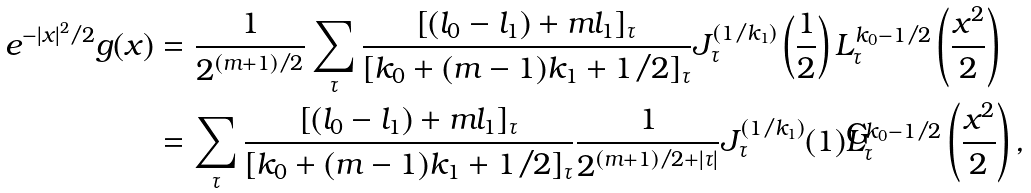<formula> <loc_0><loc_0><loc_500><loc_500>e ^ { - | x | ^ { 2 } / 2 } g ( x ) & = \frac { 1 } { 2 ^ { ( m + 1 ) / 2 } } \sum _ { \tau } \frac { [ ( l _ { 0 } - l _ { 1 } ) + m l _ { 1 } ] _ { \tau } } { [ k _ { 0 } + ( m - 1 ) k _ { 1 } + 1 / 2 ] _ { \tau } } J _ { \tau } ^ { ( 1 / k _ { 1 } ) } \left ( \frac { 1 } { 2 } \right ) L _ { \tau } ^ { k _ { 0 } - 1 / 2 } \left ( \frac { x ^ { 2 } } { 2 } \right ) \\ & = \sum _ { \tau } \frac { [ ( l _ { 0 } - l _ { 1 } ) + m l _ { 1 } ] _ { \tau } } { [ k _ { 0 } + ( m - 1 ) k _ { 1 } + 1 / 2 ] _ { \tau } } \frac { 1 } { 2 ^ { ( m + 1 ) / 2 + | \tau | } } J _ { \tau } ^ { ( 1 / k _ { 1 } ) } ( 1 ) L _ { \tau } ^ { k _ { 0 } - 1 / 2 } \left ( \frac { x ^ { 2 } } { 2 } \right ) ,</formula> 